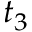<formula> <loc_0><loc_0><loc_500><loc_500>t _ { 3 }</formula> 